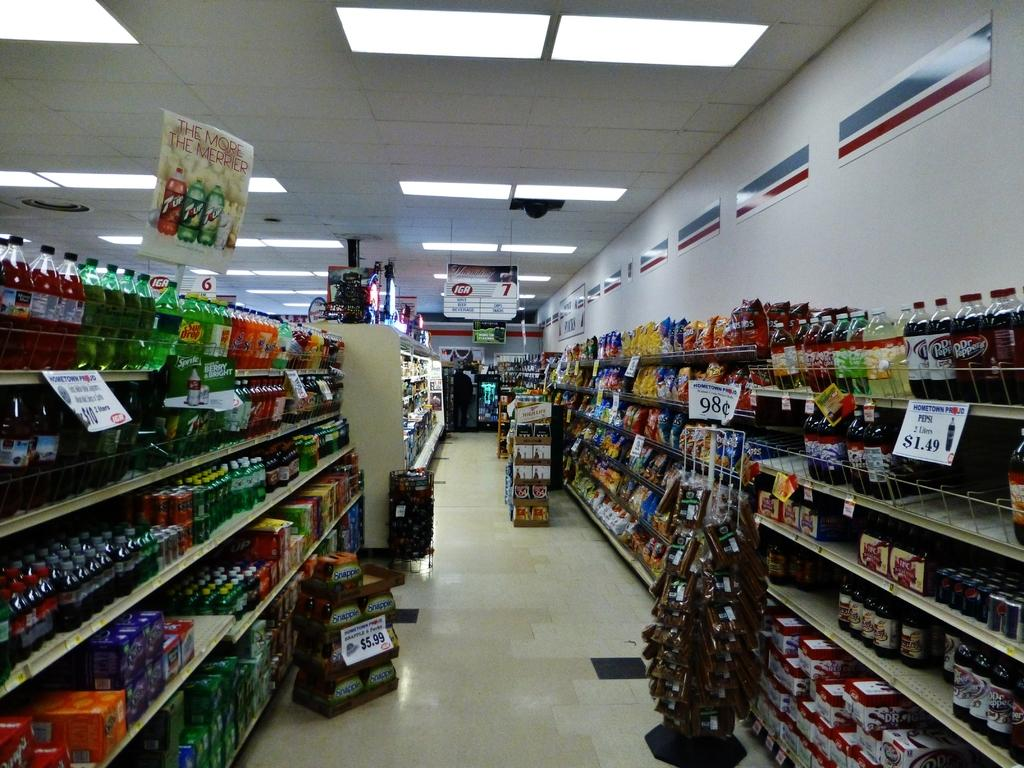<image>
Give a short and clear explanation of the subsequent image. A beverage grocery store aisle with a sign for Pepsi for $1.49. 